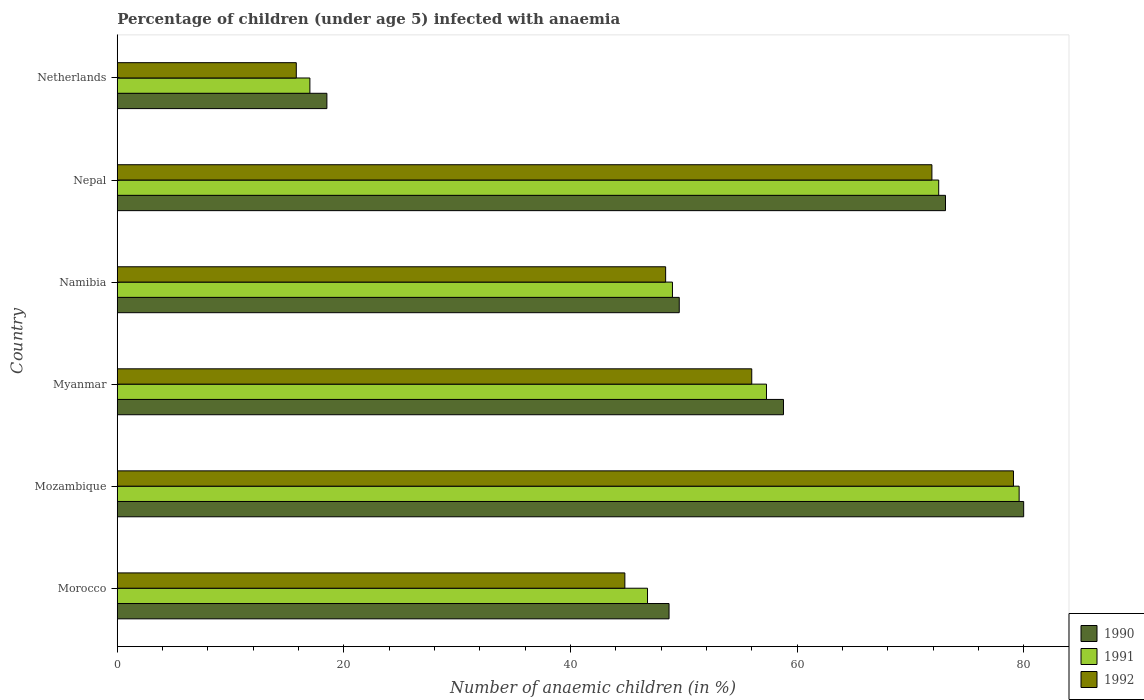How many groups of bars are there?
Give a very brief answer. 6. How many bars are there on the 2nd tick from the top?
Your response must be concise. 3. What is the label of the 2nd group of bars from the top?
Ensure brevity in your answer.  Nepal. What is the percentage of children infected with anaemia in in 1992 in Morocco?
Your answer should be very brief. 44.8. Across all countries, what is the maximum percentage of children infected with anaemia in in 1990?
Give a very brief answer. 80. Across all countries, what is the minimum percentage of children infected with anaemia in in 1990?
Provide a short and direct response. 18.5. In which country was the percentage of children infected with anaemia in in 1990 maximum?
Offer a terse response. Mozambique. What is the total percentage of children infected with anaemia in in 1991 in the graph?
Provide a short and direct response. 322.2. What is the difference between the percentage of children infected with anaemia in in 1992 in Morocco and that in Mozambique?
Provide a short and direct response. -34.3. What is the difference between the percentage of children infected with anaemia in in 1991 in Myanmar and the percentage of children infected with anaemia in in 1990 in Mozambique?
Offer a terse response. -22.7. What is the average percentage of children infected with anaemia in in 1990 per country?
Your answer should be very brief. 54.78. What is the difference between the percentage of children infected with anaemia in in 1990 and percentage of children infected with anaemia in in 1991 in Morocco?
Give a very brief answer. 1.9. What is the ratio of the percentage of children infected with anaemia in in 1991 in Mozambique to that in Netherlands?
Ensure brevity in your answer.  4.68. Is the percentage of children infected with anaemia in in 1991 in Morocco less than that in Nepal?
Your answer should be compact. Yes. What is the difference between the highest and the second highest percentage of children infected with anaemia in in 1992?
Your answer should be compact. 7.2. What is the difference between the highest and the lowest percentage of children infected with anaemia in in 1991?
Offer a terse response. 62.6. Is the sum of the percentage of children infected with anaemia in in 1991 in Mozambique and Myanmar greater than the maximum percentage of children infected with anaemia in in 1990 across all countries?
Your answer should be very brief. Yes. What does the 3rd bar from the top in Netherlands represents?
Offer a very short reply. 1990. How many bars are there?
Offer a terse response. 18. Does the graph contain any zero values?
Your response must be concise. No. Does the graph contain grids?
Give a very brief answer. No. How many legend labels are there?
Ensure brevity in your answer.  3. What is the title of the graph?
Your answer should be very brief. Percentage of children (under age 5) infected with anaemia. Does "1984" appear as one of the legend labels in the graph?
Your answer should be compact. No. What is the label or title of the X-axis?
Keep it short and to the point. Number of anaemic children (in %). What is the Number of anaemic children (in %) in 1990 in Morocco?
Provide a short and direct response. 48.7. What is the Number of anaemic children (in %) in 1991 in Morocco?
Provide a succinct answer. 46.8. What is the Number of anaemic children (in %) of 1992 in Morocco?
Make the answer very short. 44.8. What is the Number of anaemic children (in %) of 1990 in Mozambique?
Your answer should be compact. 80. What is the Number of anaemic children (in %) in 1991 in Mozambique?
Your answer should be compact. 79.6. What is the Number of anaemic children (in %) of 1992 in Mozambique?
Provide a short and direct response. 79.1. What is the Number of anaemic children (in %) in 1990 in Myanmar?
Make the answer very short. 58.8. What is the Number of anaemic children (in %) of 1991 in Myanmar?
Offer a terse response. 57.3. What is the Number of anaemic children (in %) of 1992 in Myanmar?
Your answer should be compact. 56. What is the Number of anaemic children (in %) in 1990 in Namibia?
Offer a terse response. 49.6. What is the Number of anaemic children (in %) in 1992 in Namibia?
Your answer should be very brief. 48.4. What is the Number of anaemic children (in %) of 1990 in Nepal?
Your answer should be compact. 73.1. What is the Number of anaemic children (in %) of 1991 in Nepal?
Give a very brief answer. 72.5. What is the Number of anaemic children (in %) in 1992 in Nepal?
Offer a very short reply. 71.9. What is the Number of anaemic children (in %) in 1990 in Netherlands?
Make the answer very short. 18.5. What is the Number of anaemic children (in %) in 1991 in Netherlands?
Your answer should be very brief. 17. What is the Number of anaemic children (in %) of 1992 in Netherlands?
Your answer should be very brief. 15.8. Across all countries, what is the maximum Number of anaemic children (in %) of 1990?
Your answer should be very brief. 80. Across all countries, what is the maximum Number of anaemic children (in %) of 1991?
Make the answer very short. 79.6. Across all countries, what is the maximum Number of anaemic children (in %) of 1992?
Offer a terse response. 79.1. Across all countries, what is the minimum Number of anaemic children (in %) in 1991?
Provide a succinct answer. 17. Across all countries, what is the minimum Number of anaemic children (in %) in 1992?
Your answer should be compact. 15.8. What is the total Number of anaemic children (in %) in 1990 in the graph?
Your answer should be very brief. 328.7. What is the total Number of anaemic children (in %) of 1991 in the graph?
Give a very brief answer. 322.2. What is the total Number of anaemic children (in %) of 1992 in the graph?
Provide a succinct answer. 316. What is the difference between the Number of anaemic children (in %) in 1990 in Morocco and that in Mozambique?
Make the answer very short. -31.3. What is the difference between the Number of anaemic children (in %) of 1991 in Morocco and that in Mozambique?
Offer a very short reply. -32.8. What is the difference between the Number of anaemic children (in %) of 1992 in Morocco and that in Mozambique?
Give a very brief answer. -34.3. What is the difference between the Number of anaemic children (in %) in 1992 in Morocco and that in Myanmar?
Keep it short and to the point. -11.2. What is the difference between the Number of anaemic children (in %) in 1991 in Morocco and that in Namibia?
Your answer should be very brief. -2.2. What is the difference between the Number of anaemic children (in %) of 1992 in Morocco and that in Namibia?
Provide a short and direct response. -3.6. What is the difference between the Number of anaemic children (in %) in 1990 in Morocco and that in Nepal?
Your response must be concise. -24.4. What is the difference between the Number of anaemic children (in %) in 1991 in Morocco and that in Nepal?
Make the answer very short. -25.7. What is the difference between the Number of anaemic children (in %) in 1992 in Morocco and that in Nepal?
Make the answer very short. -27.1. What is the difference between the Number of anaemic children (in %) of 1990 in Morocco and that in Netherlands?
Keep it short and to the point. 30.2. What is the difference between the Number of anaemic children (in %) in 1991 in Morocco and that in Netherlands?
Provide a succinct answer. 29.8. What is the difference between the Number of anaemic children (in %) in 1992 in Morocco and that in Netherlands?
Give a very brief answer. 29. What is the difference between the Number of anaemic children (in %) of 1990 in Mozambique and that in Myanmar?
Your answer should be very brief. 21.2. What is the difference between the Number of anaemic children (in %) in 1991 in Mozambique and that in Myanmar?
Keep it short and to the point. 22.3. What is the difference between the Number of anaemic children (in %) of 1992 in Mozambique and that in Myanmar?
Provide a succinct answer. 23.1. What is the difference between the Number of anaemic children (in %) of 1990 in Mozambique and that in Namibia?
Offer a terse response. 30.4. What is the difference between the Number of anaemic children (in %) in 1991 in Mozambique and that in Namibia?
Your response must be concise. 30.6. What is the difference between the Number of anaemic children (in %) in 1992 in Mozambique and that in Namibia?
Your answer should be compact. 30.7. What is the difference between the Number of anaemic children (in %) of 1991 in Mozambique and that in Nepal?
Make the answer very short. 7.1. What is the difference between the Number of anaemic children (in %) in 1992 in Mozambique and that in Nepal?
Provide a short and direct response. 7.2. What is the difference between the Number of anaemic children (in %) of 1990 in Mozambique and that in Netherlands?
Your answer should be compact. 61.5. What is the difference between the Number of anaemic children (in %) in 1991 in Mozambique and that in Netherlands?
Keep it short and to the point. 62.6. What is the difference between the Number of anaemic children (in %) in 1992 in Mozambique and that in Netherlands?
Your answer should be very brief. 63.3. What is the difference between the Number of anaemic children (in %) in 1990 in Myanmar and that in Namibia?
Provide a short and direct response. 9.2. What is the difference between the Number of anaemic children (in %) in 1992 in Myanmar and that in Namibia?
Your response must be concise. 7.6. What is the difference between the Number of anaemic children (in %) of 1990 in Myanmar and that in Nepal?
Keep it short and to the point. -14.3. What is the difference between the Number of anaemic children (in %) of 1991 in Myanmar and that in Nepal?
Keep it short and to the point. -15.2. What is the difference between the Number of anaemic children (in %) of 1992 in Myanmar and that in Nepal?
Make the answer very short. -15.9. What is the difference between the Number of anaemic children (in %) of 1990 in Myanmar and that in Netherlands?
Your answer should be compact. 40.3. What is the difference between the Number of anaemic children (in %) in 1991 in Myanmar and that in Netherlands?
Give a very brief answer. 40.3. What is the difference between the Number of anaemic children (in %) in 1992 in Myanmar and that in Netherlands?
Offer a terse response. 40.2. What is the difference between the Number of anaemic children (in %) of 1990 in Namibia and that in Nepal?
Make the answer very short. -23.5. What is the difference between the Number of anaemic children (in %) in 1991 in Namibia and that in Nepal?
Make the answer very short. -23.5. What is the difference between the Number of anaemic children (in %) in 1992 in Namibia and that in Nepal?
Your answer should be very brief. -23.5. What is the difference between the Number of anaemic children (in %) of 1990 in Namibia and that in Netherlands?
Your answer should be compact. 31.1. What is the difference between the Number of anaemic children (in %) in 1991 in Namibia and that in Netherlands?
Ensure brevity in your answer.  32. What is the difference between the Number of anaemic children (in %) in 1992 in Namibia and that in Netherlands?
Provide a short and direct response. 32.6. What is the difference between the Number of anaemic children (in %) in 1990 in Nepal and that in Netherlands?
Offer a very short reply. 54.6. What is the difference between the Number of anaemic children (in %) in 1991 in Nepal and that in Netherlands?
Your answer should be very brief. 55.5. What is the difference between the Number of anaemic children (in %) in 1992 in Nepal and that in Netherlands?
Provide a succinct answer. 56.1. What is the difference between the Number of anaemic children (in %) in 1990 in Morocco and the Number of anaemic children (in %) in 1991 in Mozambique?
Provide a succinct answer. -30.9. What is the difference between the Number of anaemic children (in %) of 1990 in Morocco and the Number of anaemic children (in %) of 1992 in Mozambique?
Your answer should be compact. -30.4. What is the difference between the Number of anaemic children (in %) in 1991 in Morocco and the Number of anaemic children (in %) in 1992 in Mozambique?
Give a very brief answer. -32.3. What is the difference between the Number of anaemic children (in %) of 1990 in Morocco and the Number of anaemic children (in %) of 1991 in Myanmar?
Give a very brief answer. -8.6. What is the difference between the Number of anaemic children (in %) of 1990 in Morocco and the Number of anaemic children (in %) of 1992 in Myanmar?
Offer a terse response. -7.3. What is the difference between the Number of anaemic children (in %) of 1991 in Morocco and the Number of anaemic children (in %) of 1992 in Namibia?
Give a very brief answer. -1.6. What is the difference between the Number of anaemic children (in %) of 1990 in Morocco and the Number of anaemic children (in %) of 1991 in Nepal?
Ensure brevity in your answer.  -23.8. What is the difference between the Number of anaemic children (in %) of 1990 in Morocco and the Number of anaemic children (in %) of 1992 in Nepal?
Ensure brevity in your answer.  -23.2. What is the difference between the Number of anaemic children (in %) in 1991 in Morocco and the Number of anaemic children (in %) in 1992 in Nepal?
Offer a very short reply. -25.1. What is the difference between the Number of anaemic children (in %) of 1990 in Morocco and the Number of anaemic children (in %) of 1991 in Netherlands?
Provide a short and direct response. 31.7. What is the difference between the Number of anaemic children (in %) in 1990 in Morocco and the Number of anaemic children (in %) in 1992 in Netherlands?
Ensure brevity in your answer.  32.9. What is the difference between the Number of anaemic children (in %) in 1990 in Mozambique and the Number of anaemic children (in %) in 1991 in Myanmar?
Offer a terse response. 22.7. What is the difference between the Number of anaemic children (in %) in 1990 in Mozambique and the Number of anaemic children (in %) in 1992 in Myanmar?
Give a very brief answer. 24. What is the difference between the Number of anaemic children (in %) of 1991 in Mozambique and the Number of anaemic children (in %) of 1992 in Myanmar?
Offer a terse response. 23.6. What is the difference between the Number of anaemic children (in %) in 1990 in Mozambique and the Number of anaemic children (in %) in 1991 in Namibia?
Offer a terse response. 31. What is the difference between the Number of anaemic children (in %) of 1990 in Mozambique and the Number of anaemic children (in %) of 1992 in Namibia?
Offer a terse response. 31.6. What is the difference between the Number of anaemic children (in %) in 1991 in Mozambique and the Number of anaemic children (in %) in 1992 in Namibia?
Your response must be concise. 31.2. What is the difference between the Number of anaemic children (in %) of 1990 in Mozambique and the Number of anaemic children (in %) of 1991 in Netherlands?
Provide a succinct answer. 63. What is the difference between the Number of anaemic children (in %) of 1990 in Mozambique and the Number of anaemic children (in %) of 1992 in Netherlands?
Your answer should be very brief. 64.2. What is the difference between the Number of anaemic children (in %) in 1991 in Mozambique and the Number of anaemic children (in %) in 1992 in Netherlands?
Offer a very short reply. 63.8. What is the difference between the Number of anaemic children (in %) of 1990 in Myanmar and the Number of anaemic children (in %) of 1991 in Namibia?
Ensure brevity in your answer.  9.8. What is the difference between the Number of anaemic children (in %) in 1990 in Myanmar and the Number of anaemic children (in %) in 1992 in Namibia?
Your answer should be compact. 10.4. What is the difference between the Number of anaemic children (in %) in 1990 in Myanmar and the Number of anaemic children (in %) in 1991 in Nepal?
Offer a very short reply. -13.7. What is the difference between the Number of anaemic children (in %) in 1990 in Myanmar and the Number of anaemic children (in %) in 1992 in Nepal?
Provide a succinct answer. -13.1. What is the difference between the Number of anaemic children (in %) in 1991 in Myanmar and the Number of anaemic children (in %) in 1992 in Nepal?
Your answer should be compact. -14.6. What is the difference between the Number of anaemic children (in %) in 1990 in Myanmar and the Number of anaemic children (in %) in 1991 in Netherlands?
Give a very brief answer. 41.8. What is the difference between the Number of anaemic children (in %) of 1990 in Myanmar and the Number of anaemic children (in %) of 1992 in Netherlands?
Your response must be concise. 43. What is the difference between the Number of anaemic children (in %) of 1991 in Myanmar and the Number of anaemic children (in %) of 1992 in Netherlands?
Keep it short and to the point. 41.5. What is the difference between the Number of anaemic children (in %) in 1990 in Namibia and the Number of anaemic children (in %) in 1991 in Nepal?
Offer a very short reply. -22.9. What is the difference between the Number of anaemic children (in %) of 1990 in Namibia and the Number of anaemic children (in %) of 1992 in Nepal?
Make the answer very short. -22.3. What is the difference between the Number of anaemic children (in %) in 1991 in Namibia and the Number of anaemic children (in %) in 1992 in Nepal?
Keep it short and to the point. -22.9. What is the difference between the Number of anaemic children (in %) in 1990 in Namibia and the Number of anaemic children (in %) in 1991 in Netherlands?
Offer a very short reply. 32.6. What is the difference between the Number of anaemic children (in %) in 1990 in Namibia and the Number of anaemic children (in %) in 1992 in Netherlands?
Ensure brevity in your answer.  33.8. What is the difference between the Number of anaemic children (in %) in 1991 in Namibia and the Number of anaemic children (in %) in 1992 in Netherlands?
Provide a succinct answer. 33.2. What is the difference between the Number of anaemic children (in %) of 1990 in Nepal and the Number of anaemic children (in %) of 1991 in Netherlands?
Provide a succinct answer. 56.1. What is the difference between the Number of anaemic children (in %) of 1990 in Nepal and the Number of anaemic children (in %) of 1992 in Netherlands?
Make the answer very short. 57.3. What is the difference between the Number of anaemic children (in %) in 1991 in Nepal and the Number of anaemic children (in %) in 1992 in Netherlands?
Keep it short and to the point. 56.7. What is the average Number of anaemic children (in %) in 1990 per country?
Offer a terse response. 54.78. What is the average Number of anaemic children (in %) in 1991 per country?
Provide a short and direct response. 53.7. What is the average Number of anaemic children (in %) in 1992 per country?
Offer a very short reply. 52.67. What is the difference between the Number of anaemic children (in %) in 1990 and Number of anaemic children (in %) in 1992 in Morocco?
Your answer should be compact. 3.9. What is the difference between the Number of anaemic children (in %) in 1990 and Number of anaemic children (in %) in 1991 in Mozambique?
Keep it short and to the point. 0.4. What is the difference between the Number of anaemic children (in %) of 1991 and Number of anaemic children (in %) of 1992 in Myanmar?
Provide a short and direct response. 1.3. What is the difference between the Number of anaemic children (in %) in 1990 and Number of anaemic children (in %) in 1991 in Namibia?
Your answer should be very brief. 0.6. What is the difference between the Number of anaemic children (in %) in 1990 and Number of anaemic children (in %) in 1991 in Nepal?
Keep it short and to the point. 0.6. What is the difference between the Number of anaemic children (in %) of 1990 and Number of anaemic children (in %) of 1992 in Nepal?
Give a very brief answer. 1.2. What is the difference between the Number of anaemic children (in %) of 1990 and Number of anaemic children (in %) of 1992 in Netherlands?
Ensure brevity in your answer.  2.7. What is the difference between the Number of anaemic children (in %) of 1991 and Number of anaemic children (in %) of 1992 in Netherlands?
Give a very brief answer. 1.2. What is the ratio of the Number of anaemic children (in %) in 1990 in Morocco to that in Mozambique?
Provide a short and direct response. 0.61. What is the ratio of the Number of anaemic children (in %) in 1991 in Morocco to that in Mozambique?
Ensure brevity in your answer.  0.59. What is the ratio of the Number of anaemic children (in %) of 1992 in Morocco to that in Mozambique?
Offer a very short reply. 0.57. What is the ratio of the Number of anaemic children (in %) of 1990 in Morocco to that in Myanmar?
Ensure brevity in your answer.  0.83. What is the ratio of the Number of anaemic children (in %) in 1991 in Morocco to that in Myanmar?
Provide a succinct answer. 0.82. What is the ratio of the Number of anaemic children (in %) in 1992 in Morocco to that in Myanmar?
Give a very brief answer. 0.8. What is the ratio of the Number of anaemic children (in %) in 1990 in Morocco to that in Namibia?
Make the answer very short. 0.98. What is the ratio of the Number of anaemic children (in %) in 1991 in Morocco to that in Namibia?
Make the answer very short. 0.96. What is the ratio of the Number of anaemic children (in %) in 1992 in Morocco to that in Namibia?
Provide a short and direct response. 0.93. What is the ratio of the Number of anaemic children (in %) of 1990 in Morocco to that in Nepal?
Offer a very short reply. 0.67. What is the ratio of the Number of anaemic children (in %) in 1991 in Morocco to that in Nepal?
Your answer should be very brief. 0.65. What is the ratio of the Number of anaemic children (in %) in 1992 in Morocco to that in Nepal?
Keep it short and to the point. 0.62. What is the ratio of the Number of anaemic children (in %) of 1990 in Morocco to that in Netherlands?
Make the answer very short. 2.63. What is the ratio of the Number of anaemic children (in %) of 1991 in Morocco to that in Netherlands?
Your answer should be very brief. 2.75. What is the ratio of the Number of anaemic children (in %) in 1992 in Morocco to that in Netherlands?
Your response must be concise. 2.84. What is the ratio of the Number of anaemic children (in %) in 1990 in Mozambique to that in Myanmar?
Ensure brevity in your answer.  1.36. What is the ratio of the Number of anaemic children (in %) of 1991 in Mozambique to that in Myanmar?
Keep it short and to the point. 1.39. What is the ratio of the Number of anaemic children (in %) of 1992 in Mozambique to that in Myanmar?
Make the answer very short. 1.41. What is the ratio of the Number of anaemic children (in %) of 1990 in Mozambique to that in Namibia?
Ensure brevity in your answer.  1.61. What is the ratio of the Number of anaemic children (in %) in 1991 in Mozambique to that in Namibia?
Offer a very short reply. 1.62. What is the ratio of the Number of anaemic children (in %) in 1992 in Mozambique to that in Namibia?
Give a very brief answer. 1.63. What is the ratio of the Number of anaemic children (in %) in 1990 in Mozambique to that in Nepal?
Give a very brief answer. 1.09. What is the ratio of the Number of anaemic children (in %) in 1991 in Mozambique to that in Nepal?
Give a very brief answer. 1.1. What is the ratio of the Number of anaemic children (in %) of 1992 in Mozambique to that in Nepal?
Give a very brief answer. 1.1. What is the ratio of the Number of anaemic children (in %) of 1990 in Mozambique to that in Netherlands?
Your answer should be very brief. 4.32. What is the ratio of the Number of anaemic children (in %) of 1991 in Mozambique to that in Netherlands?
Give a very brief answer. 4.68. What is the ratio of the Number of anaemic children (in %) of 1992 in Mozambique to that in Netherlands?
Make the answer very short. 5.01. What is the ratio of the Number of anaemic children (in %) in 1990 in Myanmar to that in Namibia?
Offer a terse response. 1.19. What is the ratio of the Number of anaemic children (in %) of 1991 in Myanmar to that in Namibia?
Give a very brief answer. 1.17. What is the ratio of the Number of anaemic children (in %) in 1992 in Myanmar to that in Namibia?
Make the answer very short. 1.16. What is the ratio of the Number of anaemic children (in %) of 1990 in Myanmar to that in Nepal?
Offer a terse response. 0.8. What is the ratio of the Number of anaemic children (in %) in 1991 in Myanmar to that in Nepal?
Keep it short and to the point. 0.79. What is the ratio of the Number of anaemic children (in %) of 1992 in Myanmar to that in Nepal?
Provide a short and direct response. 0.78. What is the ratio of the Number of anaemic children (in %) in 1990 in Myanmar to that in Netherlands?
Keep it short and to the point. 3.18. What is the ratio of the Number of anaemic children (in %) of 1991 in Myanmar to that in Netherlands?
Your answer should be very brief. 3.37. What is the ratio of the Number of anaemic children (in %) in 1992 in Myanmar to that in Netherlands?
Make the answer very short. 3.54. What is the ratio of the Number of anaemic children (in %) of 1990 in Namibia to that in Nepal?
Make the answer very short. 0.68. What is the ratio of the Number of anaemic children (in %) in 1991 in Namibia to that in Nepal?
Give a very brief answer. 0.68. What is the ratio of the Number of anaemic children (in %) in 1992 in Namibia to that in Nepal?
Offer a very short reply. 0.67. What is the ratio of the Number of anaemic children (in %) in 1990 in Namibia to that in Netherlands?
Offer a terse response. 2.68. What is the ratio of the Number of anaemic children (in %) of 1991 in Namibia to that in Netherlands?
Provide a succinct answer. 2.88. What is the ratio of the Number of anaemic children (in %) of 1992 in Namibia to that in Netherlands?
Your answer should be very brief. 3.06. What is the ratio of the Number of anaemic children (in %) of 1990 in Nepal to that in Netherlands?
Your answer should be compact. 3.95. What is the ratio of the Number of anaemic children (in %) of 1991 in Nepal to that in Netherlands?
Offer a terse response. 4.26. What is the ratio of the Number of anaemic children (in %) of 1992 in Nepal to that in Netherlands?
Your answer should be compact. 4.55. What is the difference between the highest and the lowest Number of anaemic children (in %) of 1990?
Offer a very short reply. 61.5. What is the difference between the highest and the lowest Number of anaemic children (in %) of 1991?
Your answer should be very brief. 62.6. What is the difference between the highest and the lowest Number of anaemic children (in %) in 1992?
Your answer should be very brief. 63.3. 